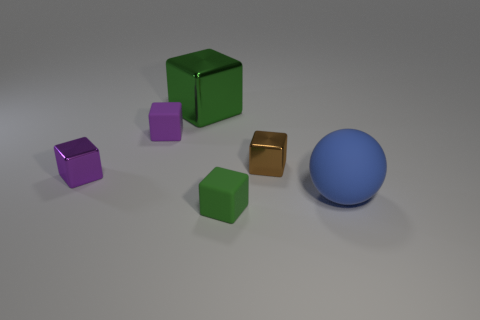Subtract all tiny brown shiny blocks. How many blocks are left? 4 Add 1 small purple things. How many objects exist? 7 Subtract all brown blocks. How many blocks are left? 4 Subtract all brown spheres. How many green blocks are left? 2 Subtract all spheres. How many objects are left? 5 Subtract 4 cubes. How many cubes are left? 1 Subtract all red spheres. Subtract all brown cylinders. How many spheres are left? 1 Subtract all tiny yellow blocks. Subtract all large green objects. How many objects are left? 5 Add 1 big rubber things. How many big rubber things are left? 2 Add 4 big things. How many big things exist? 6 